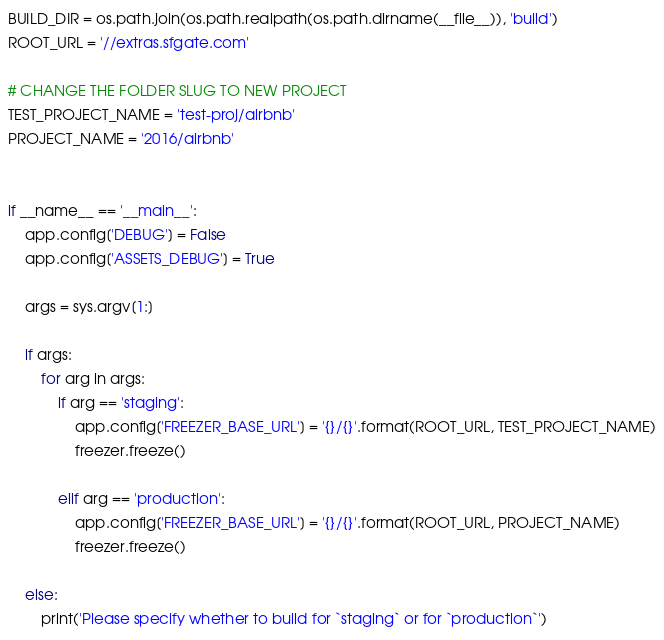Convert code to text. <code><loc_0><loc_0><loc_500><loc_500><_Python_>
BUILD_DIR = os.path.join(os.path.realpath(os.path.dirname(__file__)), 'build')
ROOT_URL = '//extras.sfgate.com'

# CHANGE THE FOLDER SLUG TO NEW PROJECT 
TEST_PROJECT_NAME = 'test-proj/airbnb'
PROJECT_NAME = '2016/airbnb'


if __name__ == '__main__':
    app.config['DEBUG'] = False
    app.config['ASSETS_DEBUG'] = True

    args = sys.argv[1:]
    
    if args:
        for arg in args: 
            if arg == 'staging':
                app.config['FREEZER_BASE_URL'] = '{}/{}'.format(ROOT_URL, TEST_PROJECT_NAME)
                freezer.freeze()

            elif arg == 'production':
                app.config['FREEZER_BASE_URL'] = '{}/{}'.format(ROOT_URL, PROJECT_NAME)
                freezer.freeze()

    else:
        print('Please specify whether to build for `staging` or for `production`')</code> 